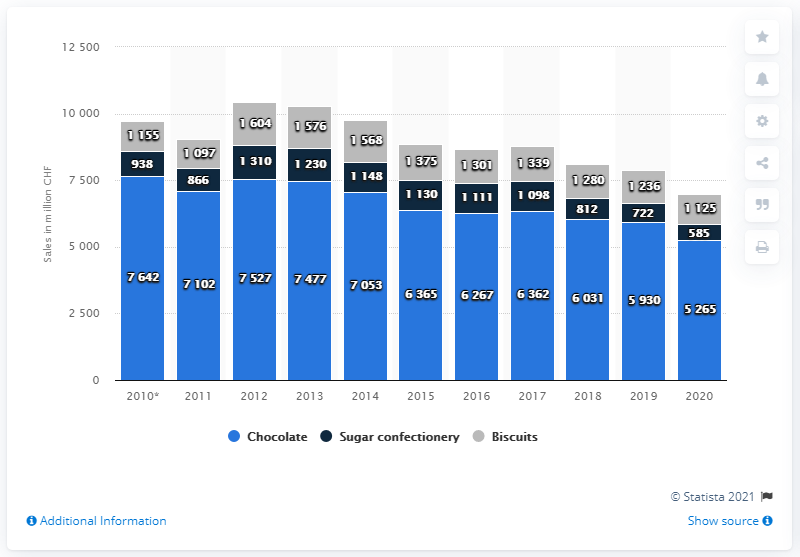List a handful of essential elements in this visual. In 2020, the total amount of sales was 6,975. According to sales data in 2020, chocolate was the most popular flavor. 